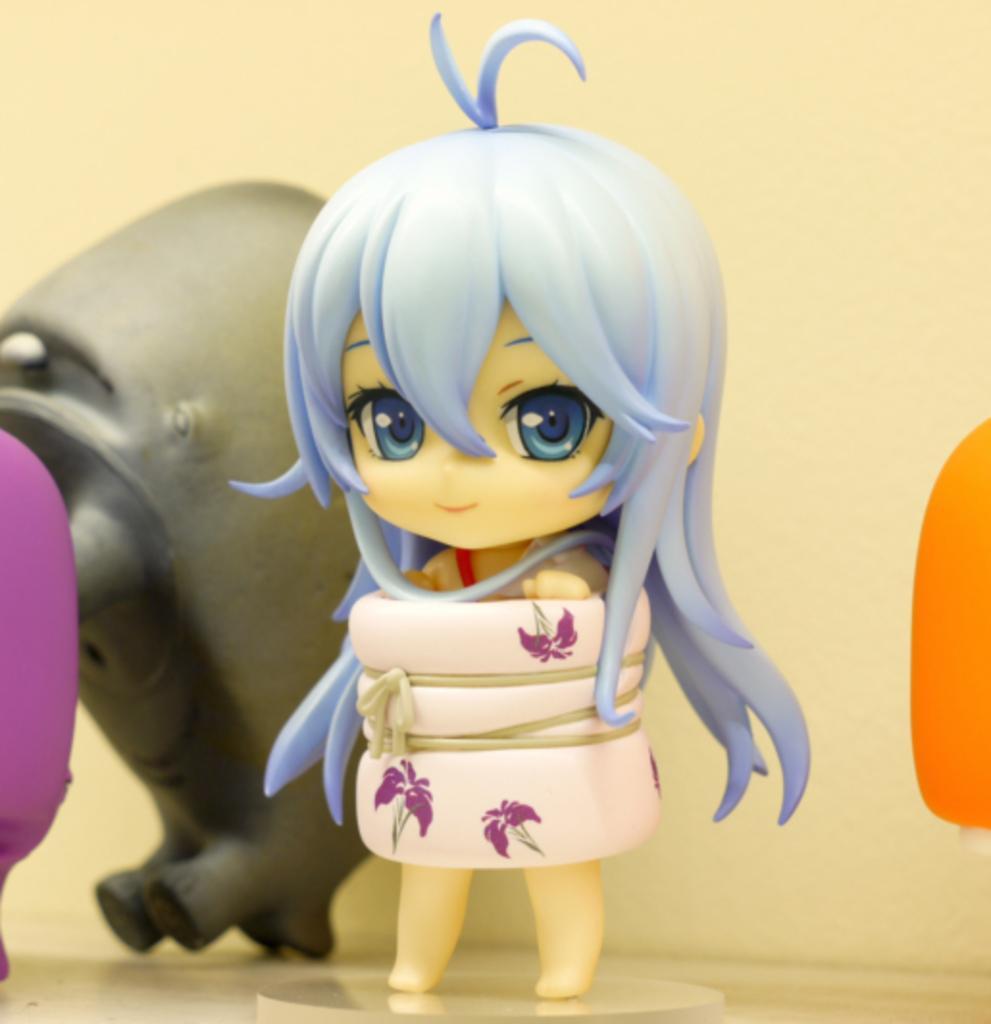Describe this image in one or two sentences. In this image we can see toys on the white surface. Background of the image, wall is there. 